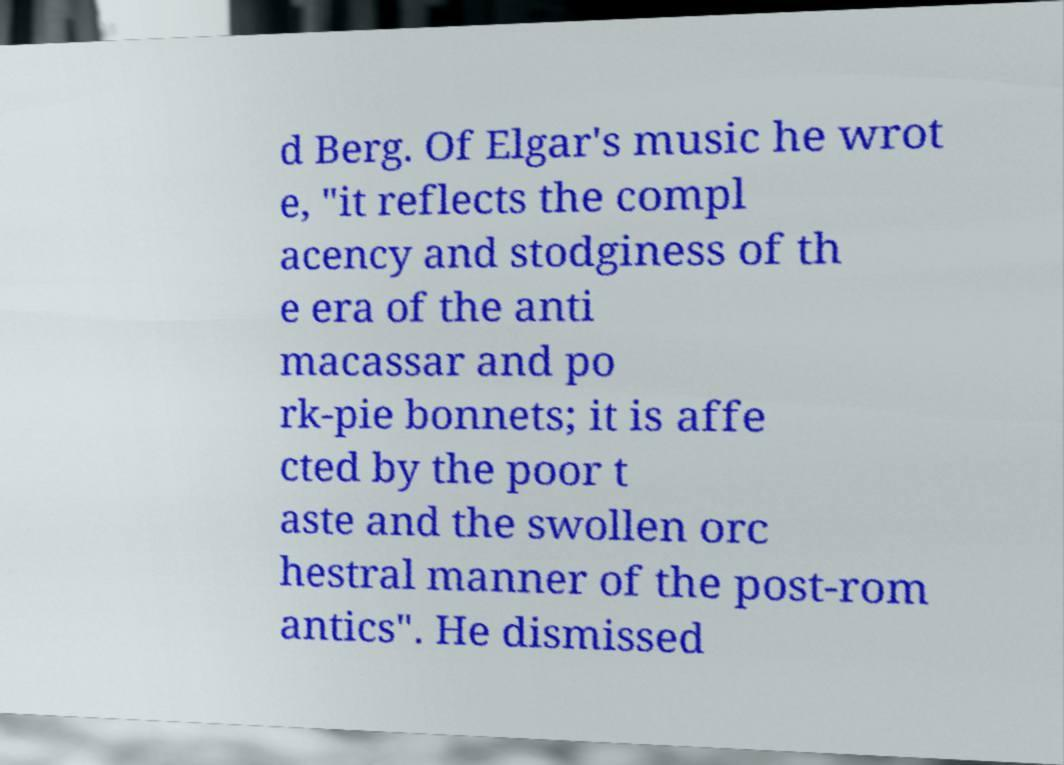Please read and relay the text visible in this image. What does it say? d Berg. Of Elgar's music he wrot e, "it reflects the compl acency and stodginess of th e era of the anti macassar and po rk-pie bonnets; it is affe cted by the poor t aste and the swollen orc hestral manner of the post-rom antics". He dismissed 